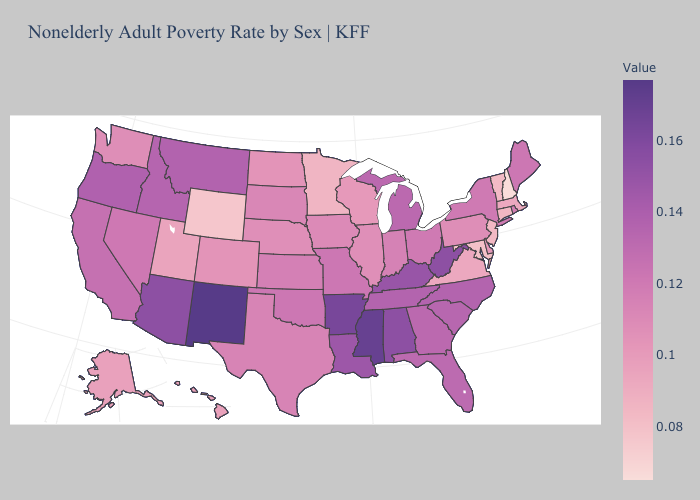Does West Virginia have a higher value than New Mexico?
Keep it brief. No. Which states have the lowest value in the West?
Write a very short answer. Wyoming. Which states hav the highest value in the West?
Be succinct. New Mexico. Does Massachusetts have a higher value than Wyoming?
Keep it brief. Yes. Does Arizona have a higher value than New Mexico?
Give a very brief answer. No. 